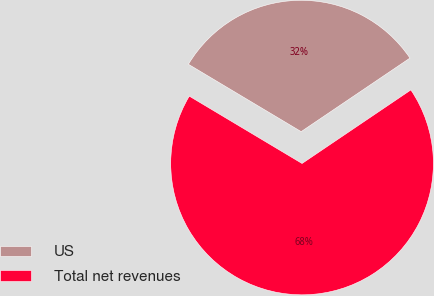Convert chart to OTSL. <chart><loc_0><loc_0><loc_500><loc_500><pie_chart><fcel>US<fcel>Total net revenues<nl><fcel>31.97%<fcel>68.03%<nl></chart> 